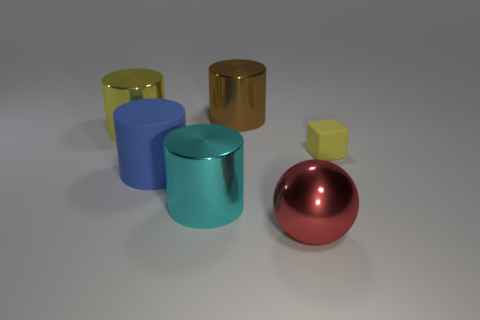Subtract all blue cylinders. How many cylinders are left? 3 Subtract all cyan cylinders. How many cylinders are left? 3 Add 1 small green cylinders. How many objects exist? 7 Subtract all spheres. How many objects are left? 5 Subtract all yellow cylinders. Subtract all cyan spheres. How many cylinders are left? 3 Add 4 big metallic objects. How many big metallic objects are left? 8 Add 5 big green objects. How many big green objects exist? 5 Subtract 0 green balls. How many objects are left? 6 Subtract all big yellow rubber blocks. Subtract all yellow metal cylinders. How many objects are left? 5 